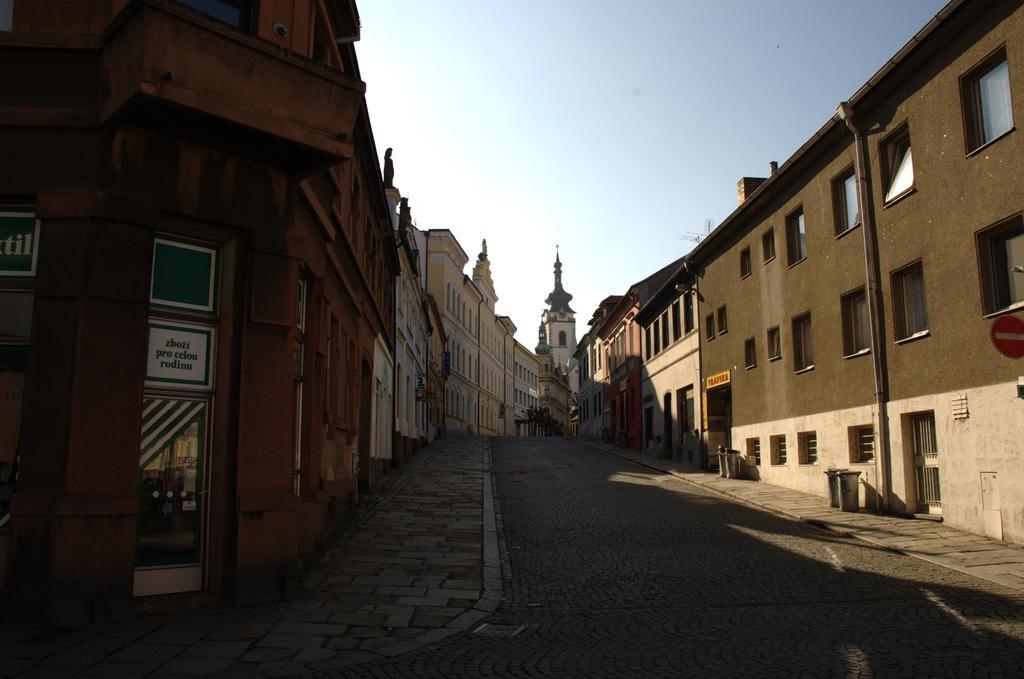Can you describe this image briefly? In the foreground of this picture, there is a street road to which buildings are on the either side to it. On the top, there is the sky. 